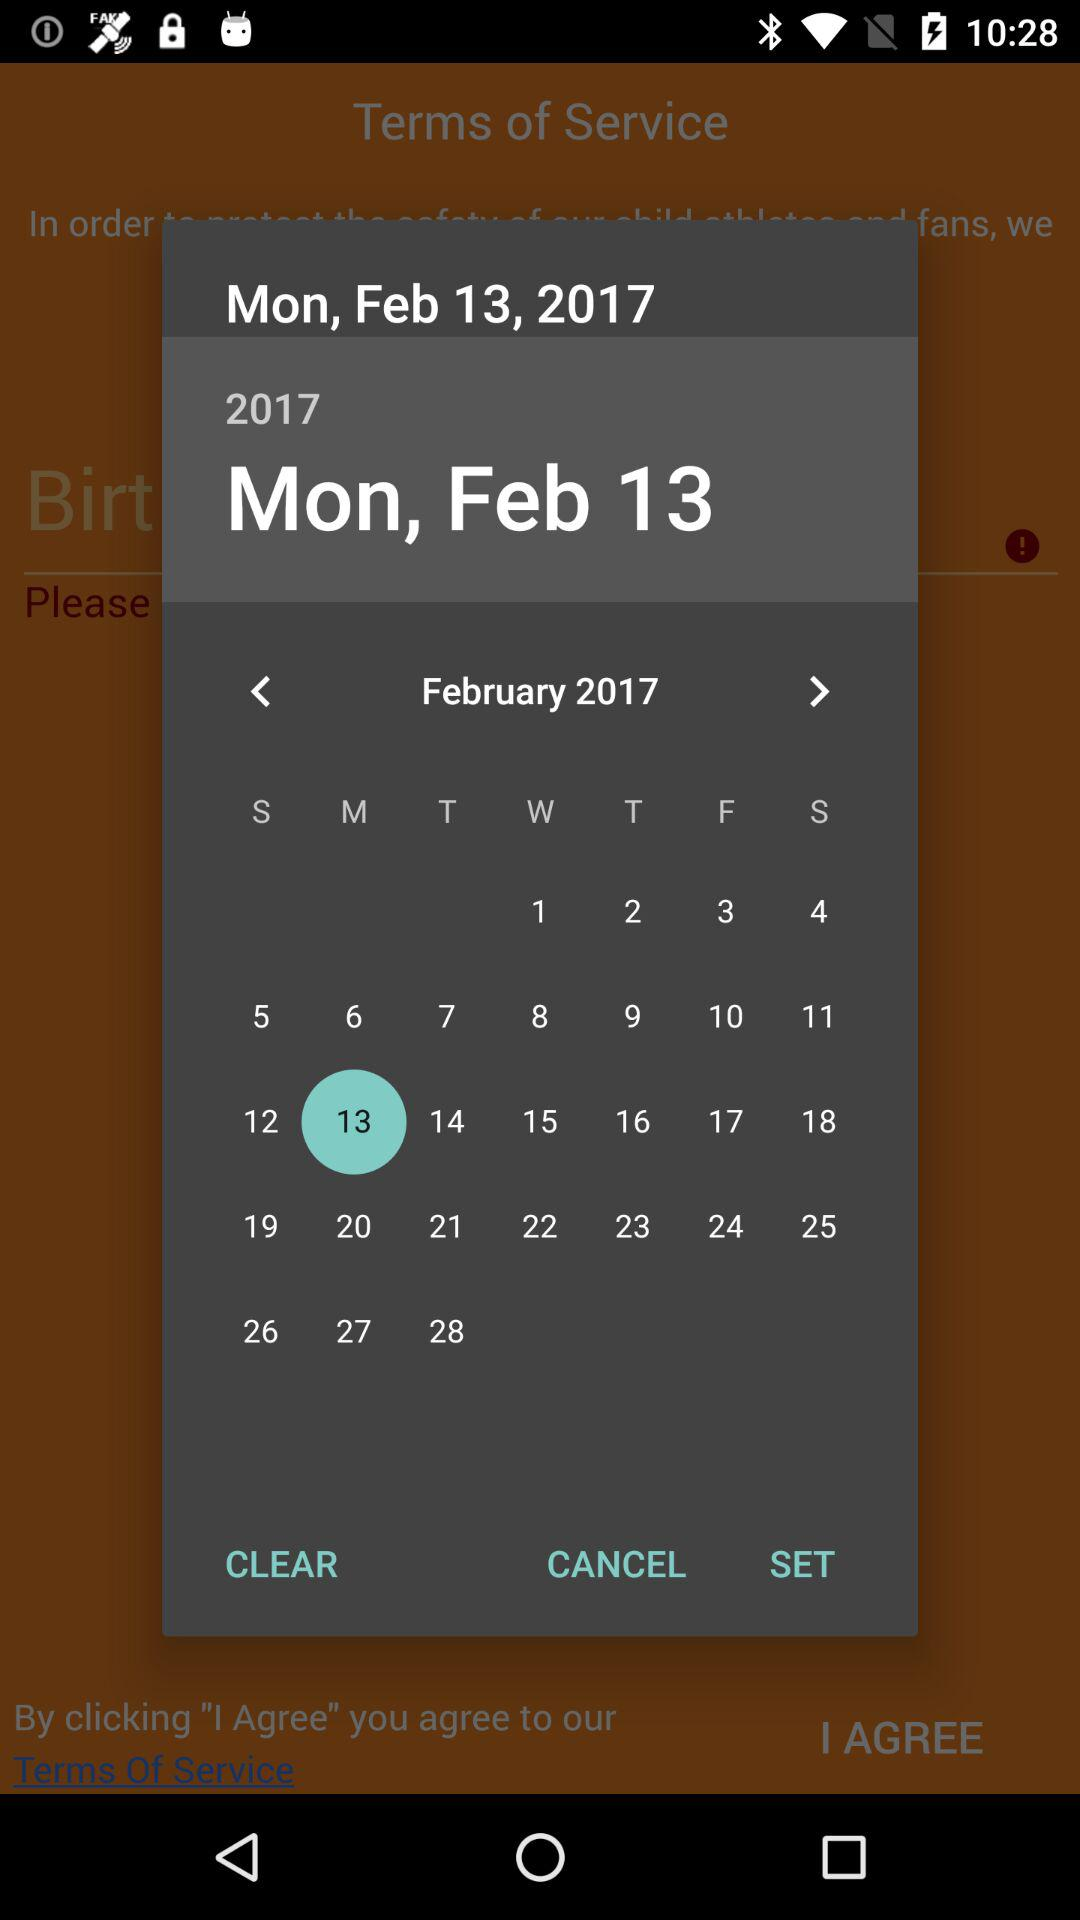Which date is selected? The selected date is Monday, February 13, 2017. 